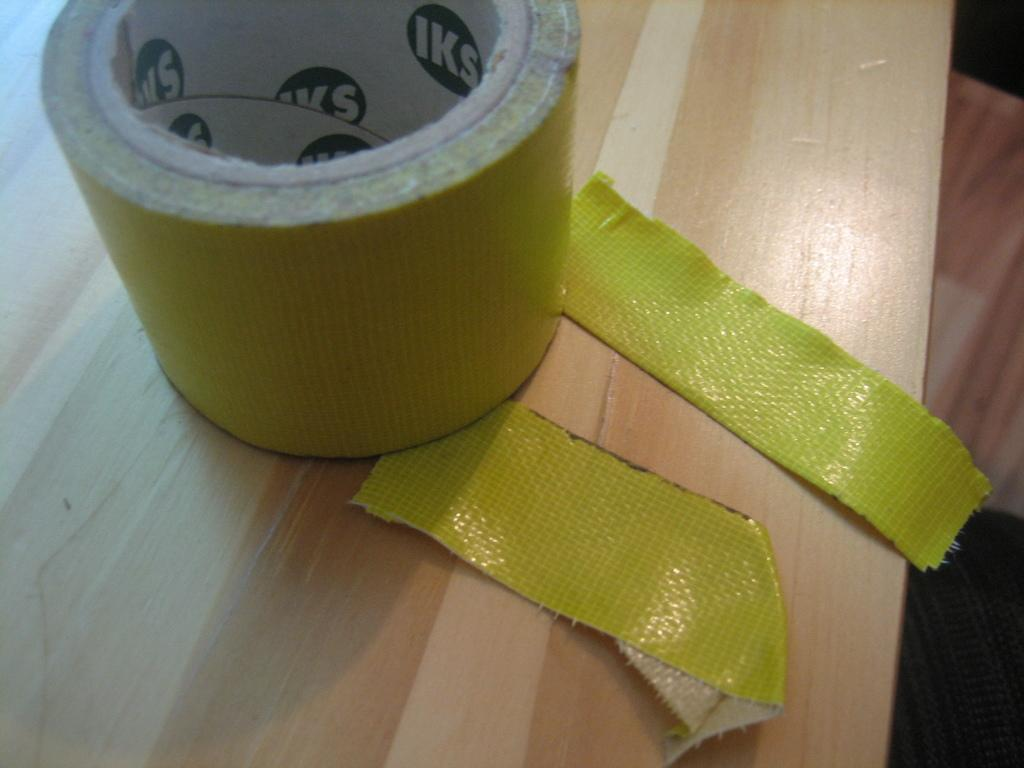What type of surface is visible in the image? There is a wooden platform in the image. What is placed on the wooden platform? There is an object on the wooden platform, which appears to be a tape. Can you describe the object on the wooden platform? The object on the wooden platform appears to be a tape. What type of music can be heard coming from the guitar in the image? There is no guitar present in the image, so it's not possible to determine what, if any, music might be heard. 